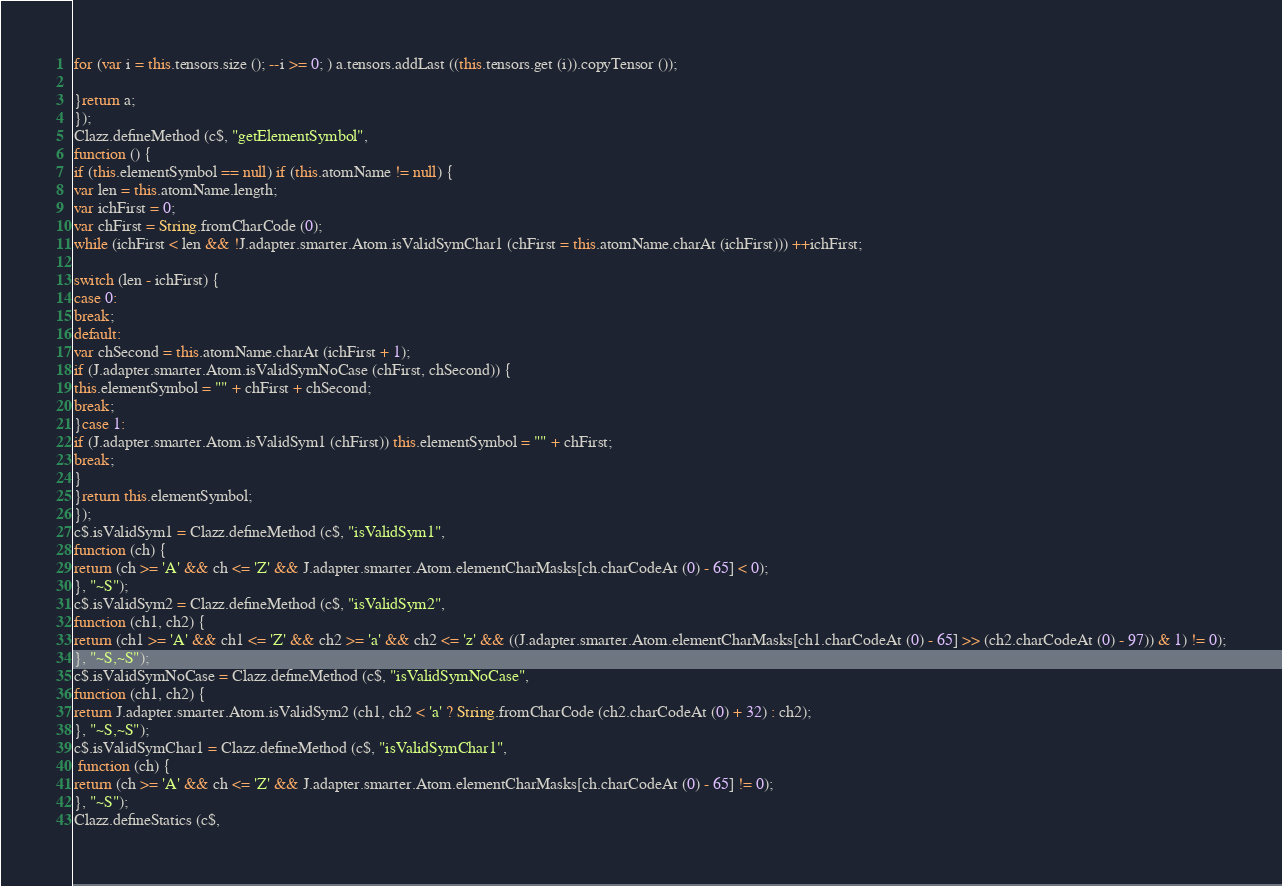Convert code to text. <code><loc_0><loc_0><loc_500><loc_500><_JavaScript_>for (var i = this.tensors.size (); --i >= 0; ) a.tensors.addLast ((this.tensors.get (i)).copyTensor ());

}return a;
});
Clazz.defineMethod (c$, "getElementSymbol", 
function () {
if (this.elementSymbol == null) if (this.atomName != null) {
var len = this.atomName.length;
var ichFirst = 0;
var chFirst = String.fromCharCode (0);
while (ichFirst < len && !J.adapter.smarter.Atom.isValidSymChar1 (chFirst = this.atomName.charAt (ichFirst))) ++ichFirst;

switch (len - ichFirst) {
case 0:
break;
default:
var chSecond = this.atomName.charAt (ichFirst + 1);
if (J.adapter.smarter.Atom.isValidSymNoCase (chFirst, chSecond)) {
this.elementSymbol = "" + chFirst + chSecond;
break;
}case 1:
if (J.adapter.smarter.Atom.isValidSym1 (chFirst)) this.elementSymbol = "" + chFirst;
break;
}
}return this.elementSymbol;
});
c$.isValidSym1 = Clazz.defineMethod (c$, "isValidSym1", 
function (ch) {
return (ch >= 'A' && ch <= 'Z' && J.adapter.smarter.Atom.elementCharMasks[ch.charCodeAt (0) - 65] < 0);
}, "~S");
c$.isValidSym2 = Clazz.defineMethod (c$, "isValidSym2", 
function (ch1, ch2) {
return (ch1 >= 'A' && ch1 <= 'Z' && ch2 >= 'a' && ch2 <= 'z' && ((J.adapter.smarter.Atom.elementCharMasks[ch1.charCodeAt (0) - 65] >> (ch2.charCodeAt (0) - 97)) & 1) != 0);
}, "~S,~S");
c$.isValidSymNoCase = Clazz.defineMethod (c$, "isValidSymNoCase", 
function (ch1, ch2) {
return J.adapter.smarter.Atom.isValidSym2 (ch1, ch2 < 'a' ? String.fromCharCode (ch2.charCodeAt (0) + 32) : ch2);
}, "~S,~S");
c$.isValidSymChar1 = Clazz.defineMethod (c$, "isValidSymChar1", 
 function (ch) {
return (ch >= 'A' && ch <= 'Z' && J.adapter.smarter.Atom.elementCharMasks[ch.charCodeAt (0) - 65] != 0);
}, "~S");
Clazz.defineStatics (c$,</code> 